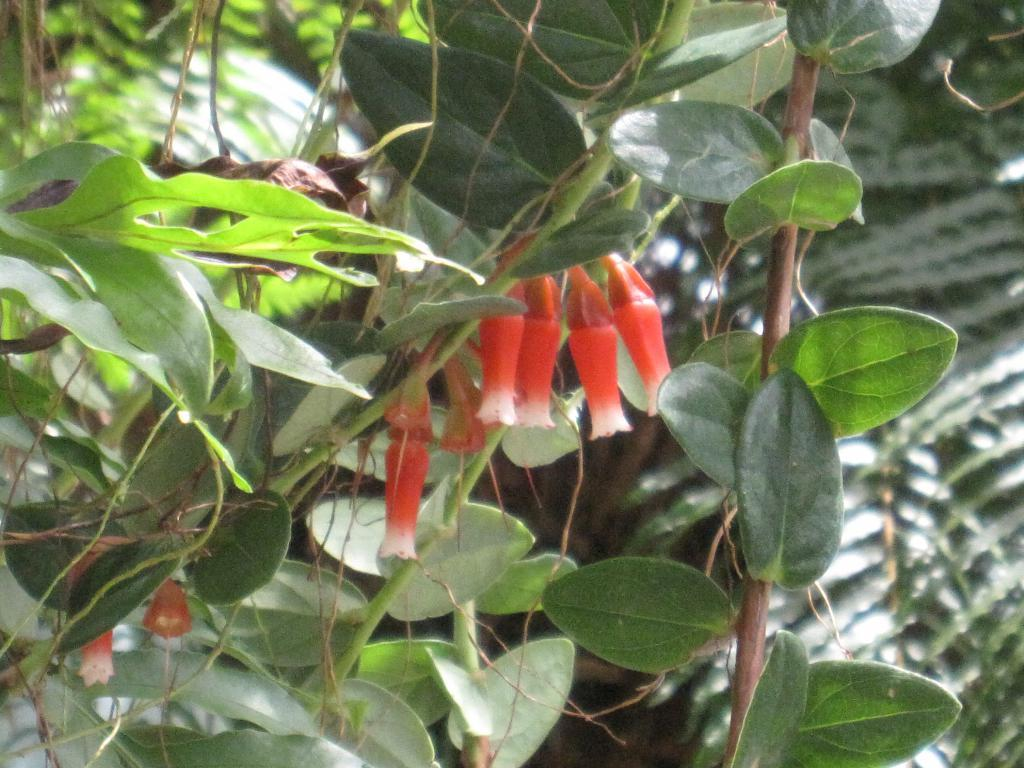What type of flowers are present in the image? There are orange flowers in the image. Where are the flowers located? The flowers are on plants. What else can be seen on the plants besides the flowers? Leaves are visible in the image. What type of hill can be seen in the background of the image? There is no hill visible in the image; it only features orange flowers on plants with leaves. 